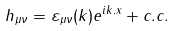<formula> <loc_0><loc_0><loc_500><loc_500>h _ { \mu \nu } = \varepsilon _ { \mu \nu } ( k ) e ^ { i k . x } + c . c .</formula> 